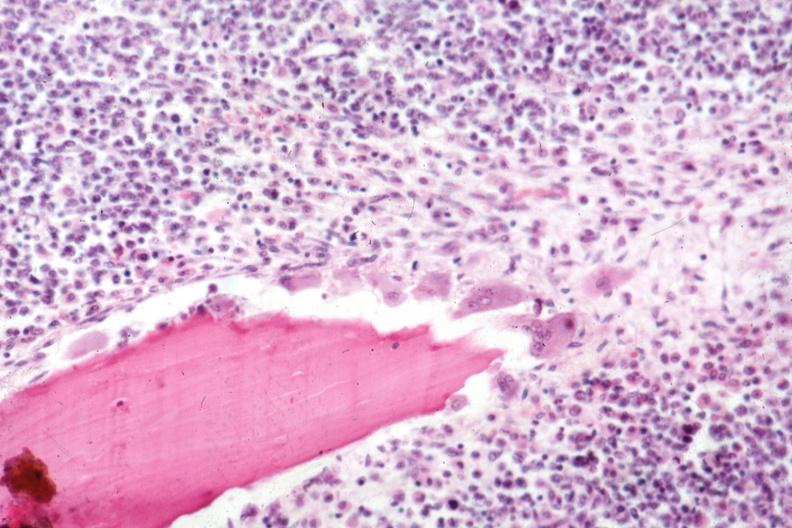does this image show osteoclasts quite well shown marrow diffuse infiltration with malignant lymphoma?
Answer the question using a single word or phrase. Yes 